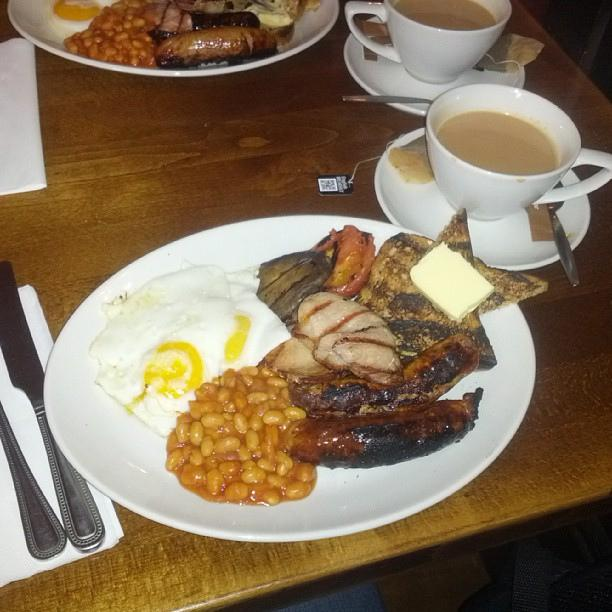What is the side dish on the plate?

Choices:
A) fries
B) tomato
C) apples
D) beans beans 